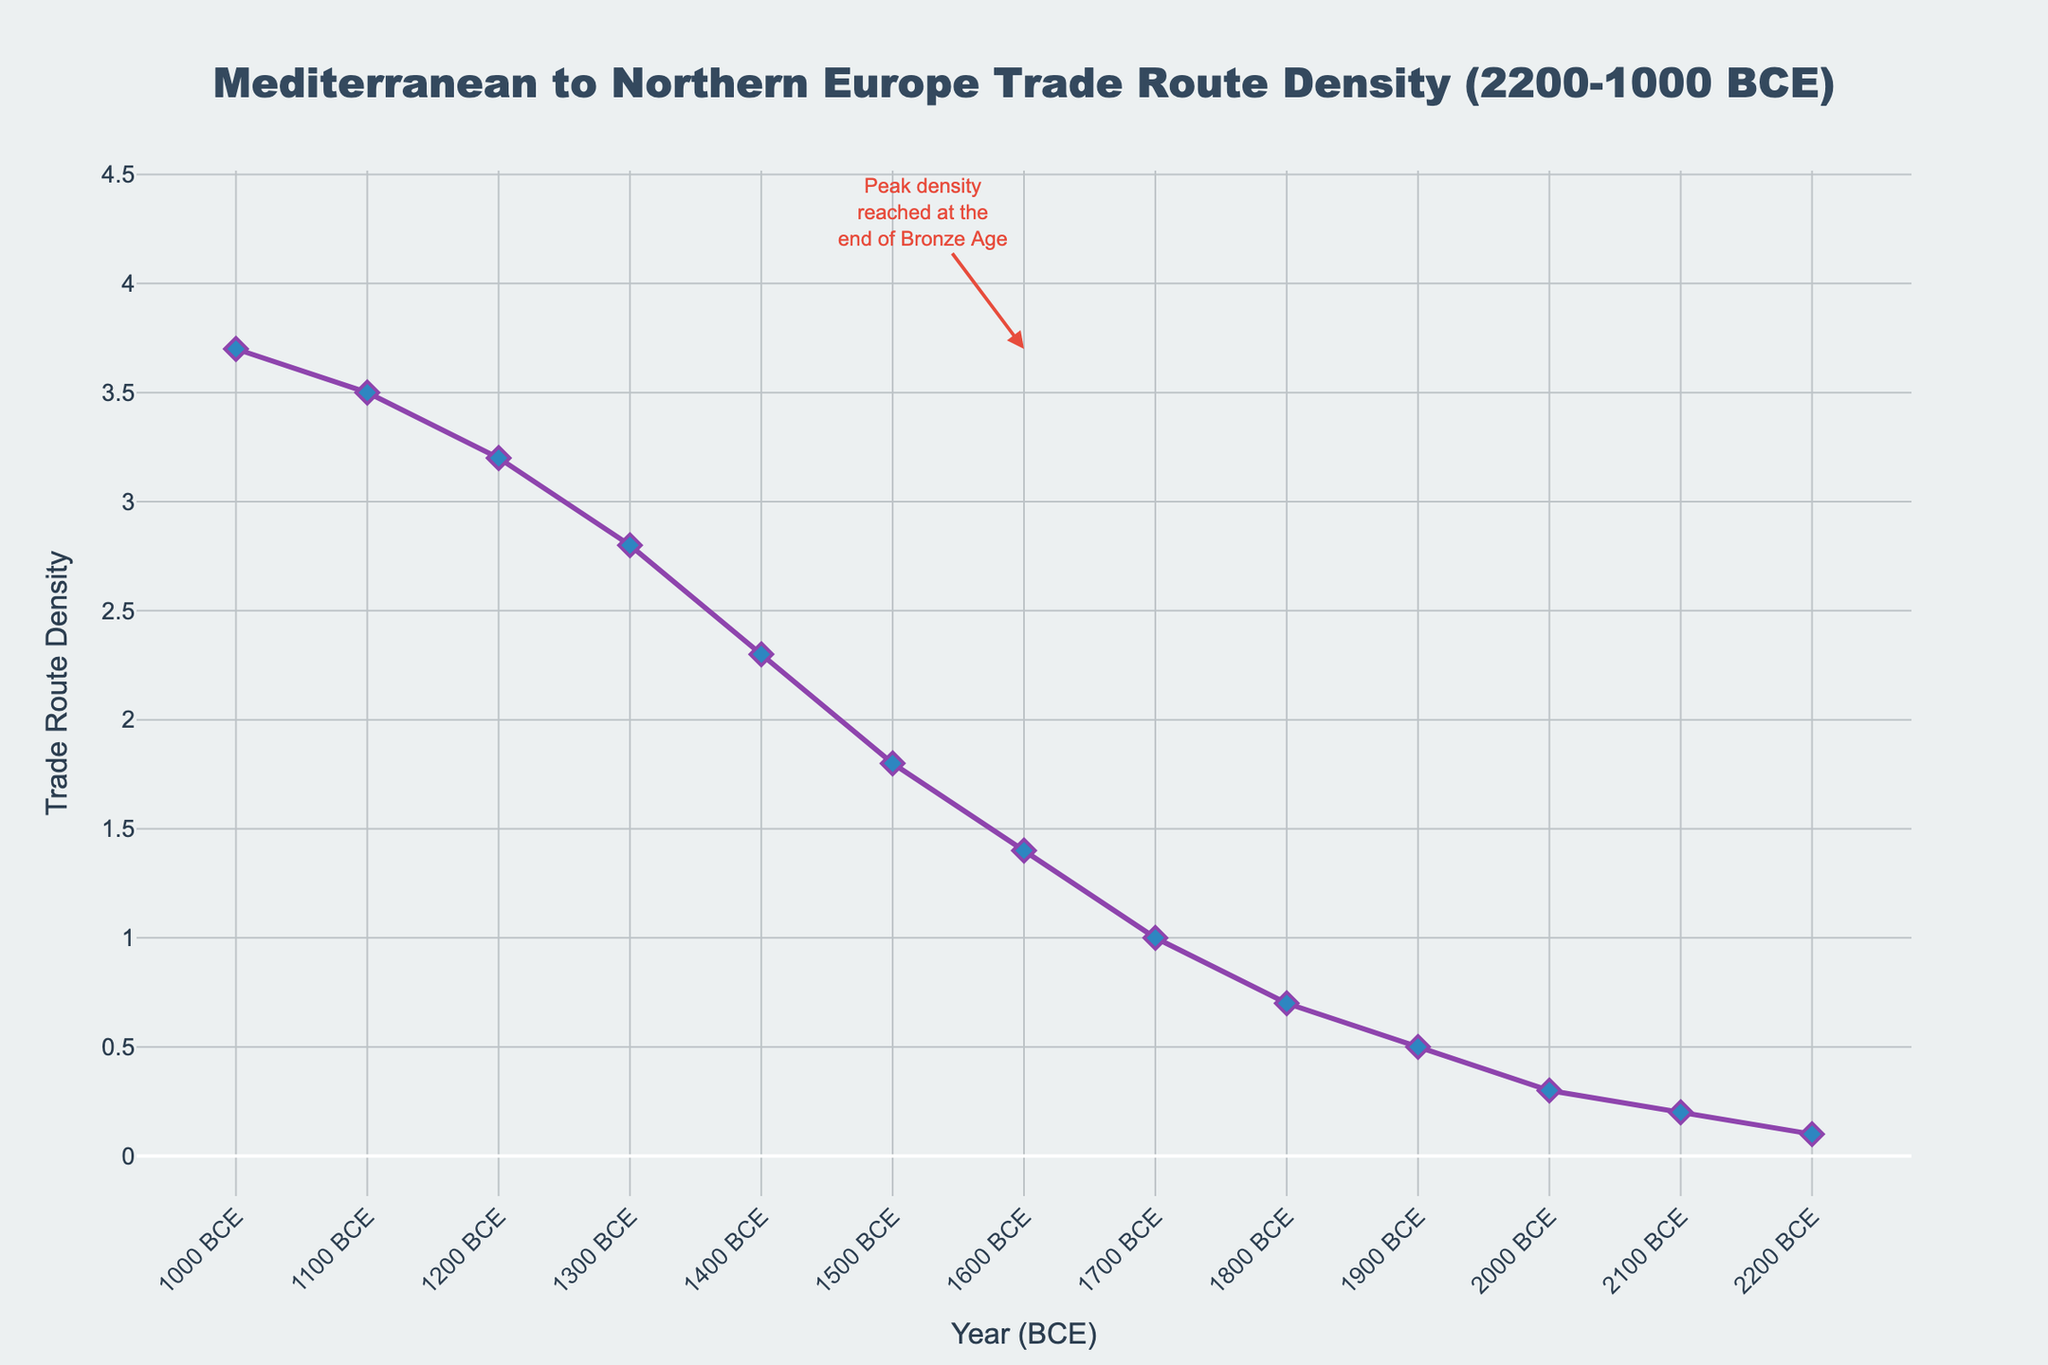What is the overall trend in trade route density between the Mediterranean and Northern Europe during the Bronze Age? Observing the line chart, there is a clear increasing trend in trade route density from 2200 BCE to 1000 BCE. The line rises steadily throughout the entire period, indicating growing trade connections.
Answer: Increasing At what period did the trade route density reach its highest value? The highest value of trade route density is marked at the point 1000 BCE, where the density is shown as 3.7. This is visually indicated by the highest point on the line chart.
Answer: 1000 BCE How much did the trade route density increase from 2200 BCE to 1000 BCE? The trade route density increased from 0.1 in 2200 BCE to 3.7 in 1000 BCE. The increase can be calculated by subtracting the initial value from the final value: 3.7 - 0.1 = 3.6.
Answer: 3.6 During which century did the trade route density experience the most significant growth? From the chart, the period with the steepest slope indicates the most significant growth. This is observed between 1800 BCE and 1600 BCE where the density jumps from 0.7 to 1.4, indicating a significant growth.
Answer: Between 1800 BCE and 1600 BCE What is the rate of increase in trade route density per century? Considering the period from 2200 BCE to 1000 BCE (1200 years) and the increase from 0.1 to 3.7, calculate the total increase: 3.7 - 0.1 = 3.6. Divide this number by the number of centuries: 3.6 / 12 = 0.3.
Answer: 0.3 per century Compare the trade route density in 1500 BCE and 1300 BCE. Which one is higher? In the provided data, the density in 1500 BCE is 1.8 and in 1300 BCE it is 2.8. Clearly, the trade route density at 1300 BCE is higher.
Answer: 1300 BCE Based on the visual attributes, what specific annotation is made on the chart and where? The chart contains an annotation at 1600 BCE, where it mentions "Peak density reached at the end of Bronze Age" with an arrow pointing to 3.7 in 1000 BCE.
Answer: Annotation at 1600 BCE If the trade route density continued to grow at the same rate after 1000 BCE, what would the density be at 900 BCE? The rate of increase is approximately 0.3 per century. Adding this to the density of 3.7 in 1000 BCE, the trade route density at 900 BCE would be 3.7 + 0.3 = 4.0.
Answer: 4.0 